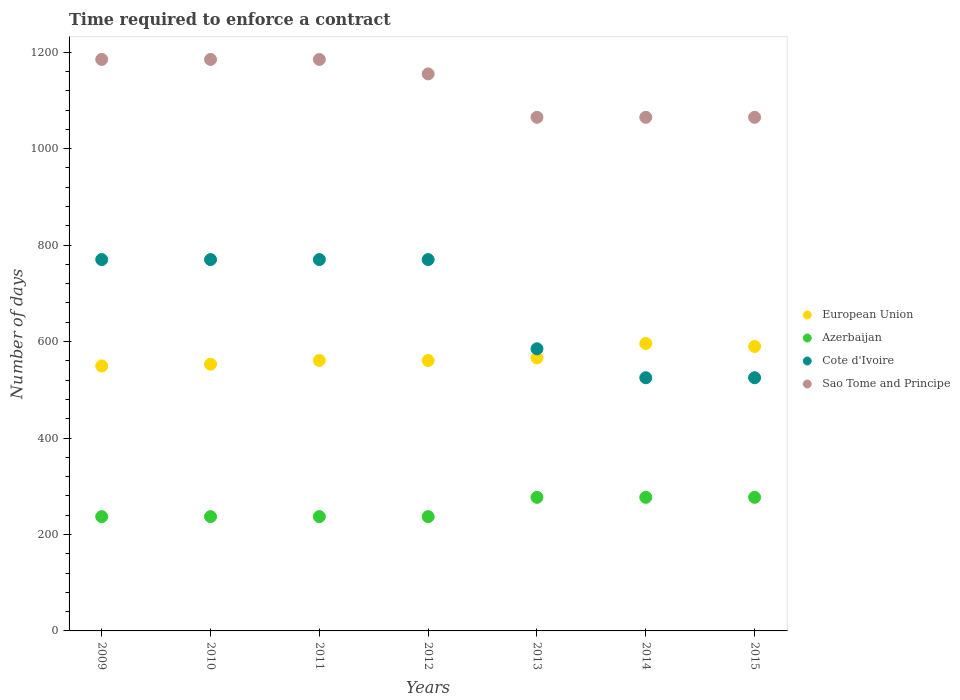How many different coloured dotlines are there?
Offer a very short reply. 4. What is the number of days required to enforce a contract in Sao Tome and Principe in 2015?
Your answer should be compact. 1065. Across all years, what is the maximum number of days required to enforce a contract in European Union?
Offer a terse response. 596.04. Across all years, what is the minimum number of days required to enforce a contract in Sao Tome and Principe?
Keep it short and to the point. 1065. What is the total number of days required to enforce a contract in Azerbaijan in the graph?
Provide a short and direct response. 1779. What is the difference between the number of days required to enforce a contract in Azerbaijan in 2010 and that in 2013?
Offer a very short reply. -40. What is the difference between the number of days required to enforce a contract in Cote d'Ivoire in 2011 and the number of days required to enforce a contract in Sao Tome and Principe in 2013?
Your response must be concise. -295. What is the average number of days required to enforce a contract in Cote d'Ivoire per year?
Keep it short and to the point. 673.57. In the year 2012, what is the difference between the number of days required to enforce a contract in European Union and number of days required to enforce a contract in Azerbaijan?
Your answer should be very brief. 323.61. In how many years, is the number of days required to enforce a contract in Cote d'Ivoire greater than 1080 days?
Offer a terse response. 0. What is the ratio of the number of days required to enforce a contract in Azerbaijan in 2009 to that in 2010?
Make the answer very short. 1. Is the difference between the number of days required to enforce a contract in European Union in 2010 and 2013 greater than the difference between the number of days required to enforce a contract in Azerbaijan in 2010 and 2013?
Make the answer very short. Yes. What is the difference between the highest and the lowest number of days required to enforce a contract in European Union?
Offer a very short reply. 46.67. In how many years, is the number of days required to enforce a contract in European Union greater than the average number of days required to enforce a contract in European Union taken over all years?
Keep it short and to the point. 2. Is the sum of the number of days required to enforce a contract in European Union in 2012 and 2014 greater than the maximum number of days required to enforce a contract in Azerbaijan across all years?
Keep it short and to the point. Yes. Is it the case that in every year, the sum of the number of days required to enforce a contract in European Union and number of days required to enforce a contract in Azerbaijan  is greater than the sum of number of days required to enforce a contract in Cote d'Ivoire and number of days required to enforce a contract in Sao Tome and Principe?
Provide a succinct answer. Yes. Is it the case that in every year, the sum of the number of days required to enforce a contract in Cote d'Ivoire and number of days required to enforce a contract in European Union  is greater than the number of days required to enforce a contract in Azerbaijan?
Give a very brief answer. Yes. Is the number of days required to enforce a contract in Cote d'Ivoire strictly greater than the number of days required to enforce a contract in Azerbaijan over the years?
Your answer should be very brief. Yes. Is the number of days required to enforce a contract in Cote d'Ivoire strictly less than the number of days required to enforce a contract in Azerbaijan over the years?
Your answer should be compact. No. How many dotlines are there?
Your answer should be compact. 4. How many years are there in the graph?
Your answer should be compact. 7. Are the values on the major ticks of Y-axis written in scientific E-notation?
Provide a succinct answer. No. Does the graph contain any zero values?
Your answer should be compact. No. Does the graph contain grids?
Your response must be concise. No. How many legend labels are there?
Make the answer very short. 4. What is the title of the graph?
Keep it short and to the point. Time required to enforce a contract. What is the label or title of the Y-axis?
Provide a short and direct response. Number of days. What is the Number of days of European Union in 2009?
Make the answer very short. 549.37. What is the Number of days of Azerbaijan in 2009?
Provide a short and direct response. 237. What is the Number of days of Cote d'Ivoire in 2009?
Make the answer very short. 770. What is the Number of days of Sao Tome and Principe in 2009?
Keep it short and to the point. 1185. What is the Number of days in European Union in 2010?
Your response must be concise. 553.07. What is the Number of days in Azerbaijan in 2010?
Give a very brief answer. 237. What is the Number of days in Cote d'Ivoire in 2010?
Give a very brief answer. 770. What is the Number of days of Sao Tome and Principe in 2010?
Keep it short and to the point. 1185. What is the Number of days of European Union in 2011?
Give a very brief answer. 560.82. What is the Number of days in Azerbaijan in 2011?
Your answer should be very brief. 237. What is the Number of days in Cote d'Ivoire in 2011?
Your response must be concise. 770. What is the Number of days of Sao Tome and Principe in 2011?
Make the answer very short. 1185. What is the Number of days in European Union in 2012?
Make the answer very short. 560.61. What is the Number of days of Azerbaijan in 2012?
Keep it short and to the point. 237. What is the Number of days of Cote d'Ivoire in 2012?
Offer a very short reply. 770. What is the Number of days in Sao Tome and Principe in 2012?
Offer a terse response. 1155. What is the Number of days of European Union in 2013?
Your answer should be very brief. 566.04. What is the Number of days in Azerbaijan in 2013?
Ensure brevity in your answer.  277. What is the Number of days in Cote d'Ivoire in 2013?
Offer a terse response. 585. What is the Number of days in Sao Tome and Principe in 2013?
Provide a succinct answer. 1065. What is the Number of days in European Union in 2014?
Your answer should be compact. 596.04. What is the Number of days of Azerbaijan in 2014?
Provide a short and direct response. 277. What is the Number of days in Cote d'Ivoire in 2014?
Your answer should be compact. 525. What is the Number of days in Sao Tome and Principe in 2014?
Keep it short and to the point. 1065. What is the Number of days of European Union in 2015?
Provide a succinct answer. 589.79. What is the Number of days of Azerbaijan in 2015?
Offer a terse response. 277. What is the Number of days of Cote d'Ivoire in 2015?
Offer a very short reply. 525. What is the Number of days in Sao Tome and Principe in 2015?
Offer a very short reply. 1065. Across all years, what is the maximum Number of days in European Union?
Offer a very short reply. 596.04. Across all years, what is the maximum Number of days in Azerbaijan?
Offer a very short reply. 277. Across all years, what is the maximum Number of days of Cote d'Ivoire?
Your answer should be very brief. 770. Across all years, what is the maximum Number of days of Sao Tome and Principe?
Offer a terse response. 1185. Across all years, what is the minimum Number of days in European Union?
Make the answer very short. 549.37. Across all years, what is the minimum Number of days in Azerbaijan?
Your response must be concise. 237. Across all years, what is the minimum Number of days of Cote d'Ivoire?
Give a very brief answer. 525. Across all years, what is the minimum Number of days in Sao Tome and Principe?
Keep it short and to the point. 1065. What is the total Number of days of European Union in the graph?
Your answer should be compact. 3975.73. What is the total Number of days of Azerbaijan in the graph?
Your response must be concise. 1779. What is the total Number of days of Cote d'Ivoire in the graph?
Keep it short and to the point. 4715. What is the total Number of days in Sao Tome and Principe in the graph?
Your response must be concise. 7905. What is the difference between the Number of days in European Union in 2009 and that in 2010?
Your answer should be compact. -3.7. What is the difference between the Number of days in Azerbaijan in 2009 and that in 2010?
Offer a very short reply. 0. What is the difference between the Number of days in European Union in 2009 and that in 2011?
Offer a terse response. -11.45. What is the difference between the Number of days in Cote d'Ivoire in 2009 and that in 2011?
Offer a very short reply. 0. What is the difference between the Number of days in Sao Tome and Principe in 2009 and that in 2011?
Provide a succinct answer. 0. What is the difference between the Number of days of European Union in 2009 and that in 2012?
Your answer should be compact. -11.24. What is the difference between the Number of days of Cote d'Ivoire in 2009 and that in 2012?
Keep it short and to the point. 0. What is the difference between the Number of days of Sao Tome and Principe in 2009 and that in 2012?
Ensure brevity in your answer.  30. What is the difference between the Number of days of European Union in 2009 and that in 2013?
Give a very brief answer. -16.67. What is the difference between the Number of days in Azerbaijan in 2009 and that in 2013?
Offer a terse response. -40. What is the difference between the Number of days of Cote d'Ivoire in 2009 and that in 2013?
Provide a succinct answer. 185. What is the difference between the Number of days in Sao Tome and Principe in 2009 and that in 2013?
Give a very brief answer. 120. What is the difference between the Number of days of European Union in 2009 and that in 2014?
Provide a succinct answer. -46.67. What is the difference between the Number of days in Cote d'Ivoire in 2009 and that in 2014?
Give a very brief answer. 245. What is the difference between the Number of days of Sao Tome and Principe in 2009 and that in 2014?
Keep it short and to the point. 120. What is the difference between the Number of days of European Union in 2009 and that in 2015?
Keep it short and to the point. -40.42. What is the difference between the Number of days in Azerbaijan in 2009 and that in 2015?
Make the answer very short. -40. What is the difference between the Number of days in Cote d'Ivoire in 2009 and that in 2015?
Your answer should be very brief. 245. What is the difference between the Number of days of Sao Tome and Principe in 2009 and that in 2015?
Your answer should be compact. 120. What is the difference between the Number of days in European Union in 2010 and that in 2011?
Ensure brevity in your answer.  -7.75. What is the difference between the Number of days of Azerbaijan in 2010 and that in 2011?
Your response must be concise. 0. What is the difference between the Number of days in Cote d'Ivoire in 2010 and that in 2011?
Your response must be concise. 0. What is the difference between the Number of days in European Union in 2010 and that in 2012?
Make the answer very short. -7.53. What is the difference between the Number of days of Sao Tome and Principe in 2010 and that in 2012?
Make the answer very short. 30. What is the difference between the Number of days of European Union in 2010 and that in 2013?
Make the answer very short. -12.96. What is the difference between the Number of days in Azerbaijan in 2010 and that in 2013?
Ensure brevity in your answer.  -40. What is the difference between the Number of days of Cote d'Ivoire in 2010 and that in 2013?
Offer a terse response. 185. What is the difference between the Number of days in Sao Tome and Principe in 2010 and that in 2013?
Offer a terse response. 120. What is the difference between the Number of days in European Union in 2010 and that in 2014?
Your answer should be compact. -42.96. What is the difference between the Number of days of Azerbaijan in 2010 and that in 2014?
Offer a terse response. -40. What is the difference between the Number of days of Cote d'Ivoire in 2010 and that in 2014?
Provide a short and direct response. 245. What is the difference between the Number of days of Sao Tome and Principe in 2010 and that in 2014?
Offer a terse response. 120. What is the difference between the Number of days in European Union in 2010 and that in 2015?
Provide a short and direct response. -36.71. What is the difference between the Number of days in Cote d'Ivoire in 2010 and that in 2015?
Ensure brevity in your answer.  245. What is the difference between the Number of days of Sao Tome and Principe in 2010 and that in 2015?
Offer a very short reply. 120. What is the difference between the Number of days in European Union in 2011 and that in 2012?
Offer a very short reply. 0.21. What is the difference between the Number of days in Azerbaijan in 2011 and that in 2012?
Ensure brevity in your answer.  0. What is the difference between the Number of days of Cote d'Ivoire in 2011 and that in 2012?
Ensure brevity in your answer.  0. What is the difference between the Number of days of Sao Tome and Principe in 2011 and that in 2012?
Make the answer very short. 30. What is the difference between the Number of days in European Union in 2011 and that in 2013?
Ensure brevity in your answer.  -5.21. What is the difference between the Number of days of Azerbaijan in 2011 and that in 2013?
Give a very brief answer. -40. What is the difference between the Number of days of Cote d'Ivoire in 2011 and that in 2013?
Give a very brief answer. 185. What is the difference between the Number of days of Sao Tome and Principe in 2011 and that in 2013?
Offer a terse response. 120. What is the difference between the Number of days of European Union in 2011 and that in 2014?
Offer a very short reply. -35.21. What is the difference between the Number of days in Cote d'Ivoire in 2011 and that in 2014?
Offer a very short reply. 245. What is the difference between the Number of days in Sao Tome and Principe in 2011 and that in 2014?
Offer a terse response. 120. What is the difference between the Number of days of European Union in 2011 and that in 2015?
Your answer should be compact. -28.96. What is the difference between the Number of days of Cote d'Ivoire in 2011 and that in 2015?
Keep it short and to the point. 245. What is the difference between the Number of days in Sao Tome and Principe in 2011 and that in 2015?
Make the answer very short. 120. What is the difference between the Number of days of European Union in 2012 and that in 2013?
Offer a terse response. -5.43. What is the difference between the Number of days in Cote d'Ivoire in 2012 and that in 2013?
Your response must be concise. 185. What is the difference between the Number of days of Sao Tome and Principe in 2012 and that in 2013?
Offer a terse response. 90. What is the difference between the Number of days in European Union in 2012 and that in 2014?
Keep it short and to the point. -35.43. What is the difference between the Number of days of Azerbaijan in 2012 and that in 2014?
Keep it short and to the point. -40. What is the difference between the Number of days of Cote d'Ivoire in 2012 and that in 2014?
Offer a very short reply. 245. What is the difference between the Number of days in Sao Tome and Principe in 2012 and that in 2014?
Ensure brevity in your answer.  90. What is the difference between the Number of days of European Union in 2012 and that in 2015?
Provide a short and direct response. -29.18. What is the difference between the Number of days of Azerbaijan in 2012 and that in 2015?
Keep it short and to the point. -40. What is the difference between the Number of days in Cote d'Ivoire in 2012 and that in 2015?
Offer a terse response. 245. What is the difference between the Number of days in European Union in 2013 and that in 2015?
Keep it short and to the point. -23.75. What is the difference between the Number of days in Azerbaijan in 2013 and that in 2015?
Offer a terse response. 0. What is the difference between the Number of days in Sao Tome and Principe in 2013 and that in 2015?
Offer a very short reply. 0. What is the difference between the Number of days in European Union in 2014 and that in 2015?
Make the answer very short. 6.25. What is the difference between the Number of days in Cote d'Ivoire in 2014 and that in 2015?
Your response must be concise. 0. What is the difference between the Number of days of Sao Tome and Principe in 2014 and that in 2015?
Your answer should be very brief. 0. What is the difference between the Number of days in European Union in 2009 and the Number of days in Azerbaijan in 2010?
Your answer should be very brief. 312.37. What is the difference between the Number of days in European Union in 2009 and the Number of days in Cote d'Ivoire in 2010?
Provide a short and direct response. -220.63. What is the difference between the Number of days of European Union in 2009 and the Number of days of Sao Tome and Principe in 2010?
Provide a succinct answer. -635.63. What is the difference between the Number of days in Azerbaijan in 2009 and the Number of days in Cote d'Ivoire in 2010?
Offer a very short reply. -533. What is the difference between the Number of days of Azerbaijan in 2009 and the Number of days of Sao Tome and Principe in 2010?
Provide a succinct answer. -948. What is the difference between the Number of days in Cote d'Ivoire in 2009 and the Number of days in Sao Tome and Principe in 2010?
Your answer should be compact. -415. What is the difference between the Number of days of European Union in 2009 and the Number of days of Azerbaijan in 2011?
Keep it short and to the point. 312.37. What is the difference between the Number of days in European Union in 2009 and the Number of days in Cote d'Ivoire in 2011?
Ensure brevity in your answer.  -220.63. What is the difference between the Number of days in European Union in 2009 and the Number of days in Sao Tome and Principe in 2011?
Give a very brief answer. -635.63. What is the difference between the Number of days of Azerbaijan in 2009 and the Number of days of Cote d'Ivoire in 2011?
Provide a short and direct response. -533. What is the difference between the Number of days in Azerbaijan in 2009 and the Number of days in Sao Tome and Principe in 2011?
Offer a very short reply. -948. What is the difference between the Number of days of Cote d'Ivoire in 2009 and the Number of days of Sao Tome and Principe in 2011?
Ensure brevity in your answer.  -415. What is the difference between the Number of days of European Union in 2009 and the Number of days of Azerbaijan in 2012?
Provide a succinct answer. 312.37. What is the difference between the Number of days of European Union in 2009 and the Number of days of Cote d'Ivoire in 2012?
Provide a succinct answer. -220.63. What is the difference between the Number of days in European Union in 2009 and the Number of days in Sao Tome and Principe in 2012?
Give a very brief answer. -605.63. What is the difference between the Number of days of Azerbaijan in 2009 and the Number of days of Cote d'Ivoire in 2012?
Your response must be concise. -533. What is the difference between the Number of days of Azerbaijan in 2009 and the Number of days of Sao Tome and Principe in 2012?
Ensure brevity in your answer.  -918. What is the difference between the Number of days in Cote d'Ivoire in 2009 and the Number of days in Sao Tome and Principe in 2012?
Your answer should be compact. -385. What is the difference between the Number of days in European Union in 2009 and the Number of days in Azerbaijan in 2013?
Your response must be concise. 272.37. What is the difference between the Number of days in European Union in 2009 and the Number of days in Cote d'Ivoire in 2013?
Offer a very short reply. -35.63. What is the difference between the Number of days in European Union in 2009 and the Number of days in Sao Tome and Principe in 2013?
Provide a short and direct response. -515.63. What is the difference between the Number of days of Azerbaijan in 2009 and the Number of days of Cote d'Ivoire in 2013?
Your answer should be compact. -348. What is the difference between the Number of days in Azerbaijan in 2009 and the Number of days in Sao Tome and Principe in 2013?
Offer a terse response. -828. What is the difference between the Number of days of Cote d'Ivoire in 2009 and the Number of days of Sao Tome and Principe in 2013?
Provide a short and direct response. -295. What is the difference between the Number of days of European Union in 2009 and the Number of days of Azerbaijan in 2014?
Give a very brief answer. 272.37. What is the difference between the Number of days of European Union in 2009 and the Number of days of Cote d'Ivoire in 2014?
Make the answer very short. 24.37. What is the difference between the Number of days in European Union in 2009 and the Number of days in Sao Tome and Principe in 2014?
Keep it short and to the point. -515.63. What is the difference between the Number of days of Azerbaijan in 2009 and the Number of days of Cote d'Ivoire in 2014?
Provide a short and direct response. -288. What is the difference between the Number of days in Azerbaijan in 2009 and the Number of days in Sao Tome and Principe in 2014?
Your answer should be very brief. -828. What is the difference between the Number of days of Cote d'Ivoire in 2009 and the Number of days of Sao Tome and Principe in 2014?
Offer a very short reply. -295. What is the difference between the Number of days in European Union in 2009 and the Number of days in Azerbaijan in 2015?
Make the answer very short. 272.37. What is the difference between the Number of days of European Union in 2009 and the Number of days of Cote d'Ivoire in 2015?
Offer a very short reply. 24.37. What is the difference between the Number of days in European Union in 2009 and the Number of days in Sao Tome and Principe in 2015?
Provide a succinct answer. -515.63. What is the difference between the Number of days of Azerbaijan in 2009 and the Number of days of Cote d'Ivoire in 2015?
Provide a succinct answer. -288. What is the difference between the Number of days of Azerbaijan in 2009 and the Number of days of Sao Tome and Principe in 2015?
Keep it short and to the point. -828. What is the difference between the Number of days of Cote d'Ivoire in 2009 and the Number of days of Sao Tome and Principe in 2015?
Your answer should be compact. -295. What is the difference between the Number of days in European Union in 2010 and the Number of days in Azerbaijan in 2011?
Give a very brief answer. 316.07. What is the difference between the Number of days of European Union in 2010 and the Number of days of Cote d'Ivoire in 2011?
Ensure brevity in your answer.  -216.93. What is the difference between the Number of days in European Union in 2010 and the Number of days in Sao Tome and Principe in 2011?
Make the answer very short. -631.93. What is the difference between the Number of days in Azerbaijan in 2010 and the Number of days in Cote d'Ivoire in 2011?
Your answer should be very brief. -533. What is the difference between the Number of days in Azerbaijan in 2010 and the Number of days in Sao Tome and Principe in 2011?
Your response must be concise. -948. What is the difference between the Number of days of Cote d'Ivoire in 2010 and the Number of days of Sao Tome and Principe in 2011?
Your answer should be very brief. -415. What is the difference between the Number of days of European Union in 2010 and the Number of days of Azerbaijan in 2012?
Offer a terse response. 316.07. What is the difference between the Number of days in European Union in 2010 and the Number of days in Cote d'Ivoire in 2012?
Provide a short and direct response. -216.93. What is the difference between the Number of days in European Union in 2010 and the Number of days in Sao Tome and Principe in 2012?
Offer a very short reply. -601.93. What is the difference between the Number of days in Azerbaijan in 2010 and the Number of days in Cote d'Ivoire in 2012?
Your answer should be compact. -533. What is the difference between the Number of days of Azerbaijan in 2010 and the Number of days of Sao Tome and Principe in 2012?
Offer a terse response. -918. What is the difference between the Number of days of Cote d'Ivoire in 2010 and the Number of days of Sao Tome and Principe in 2012?
Your answer should be very brief. -385. What is the difference between the Number of days in European Union in 2010 and the Number of days in Azerbaijan in 2013?
Offer a terse response. 276.07. What is the difference between the Number of days of European Union in 2010 and the Number of days of Cote d'Ivoire in 2013?
Make the answer very short. -31.93. What is the difference between the Number of days of European Union in 2010 and the Number of days of Sao Tome and Principe in 2013?
Your answer should be very brief. -511.93. What is the difference between the Number of days in Azerbaijan in 2010 and the Number of days in Cote d'Ivoire in 2013?
Offer a very short reply. -348. What is the difference between the Number of days in Azerbaijan in 2010 and the Number of days in Sao Tome and Principe in 2013?
Provide a succinct answer. -828. What is the difference between the Number of days in Cote d'Ivoire in 2010 and the Number of days in Sao Tome and Principe in 2013?
Provide a short and direct response. -295. What is the difference between the Number of days of European Union in 2010 and the Number of days of Azerbaijan in 2014?
Provide a short and direct response. 276.07. What is the difference between the Number of days in European Union in 2010 and the Number of days in Cote d'Ivoire in 2014?
Your answer should be very brief. 28.07. What is the difference between the Number of days in European Union in 2010 and the Number of days in Sao Tome and Principe in 2014?
Give a very brief answer. -511.93. What is the difference between the Number of days of Azerbaijan in 2010 and the Number of days of Cote d'Ivoire in 2014?
Your answer should be compact. -288. What is the difference between the Number of days in Azerbaijan in 2010 and the Number of days in Sao Tome and Principe in 2014?
Your response must be concise. -828. What is the difference between the Number of days in Cote d'Ivoire in 2010 and the Number of days in Sao Tome and Principe in 2014?
Make the answer very short. -295. What is the difference between the Number of days of European Union in 2010 and the Number of days of Azerbaijan in 2015?
Keep it short and to the point. 276.07. What is the difference between the Number of days of European Union in 2010 and the Number of days of Cote d'Ivoire in 2015?
Keep it short and to the point. 28.07. What is the difference between the Number of days in European Union in 2010 and the Number of days in Sao Tome and Principe in 2015?
Make the answer very short. -511.93. What is the difference between the Number of days of Azerbaijan in 2010 and the Number of days of Cote d'Ivoire in 2015?
Give a very brief answer. -288. What is the difference between the Number of days in Azerbaijan in 2010 and the Number of days in Sao Tome and Principe in 2015?
Your response must be concise. -828. What is the difference between the Number of days of Cote d'Ivoire in 2010 and the Number of days of Sao Tome and Principe in 2015?
Keep it short and to the point. -295. What is the difference between the Number of days of European Union in 2011 and the Number of days of Azerbaijan in 2012?
Provide a succinct answer. 323.82. What is the difference between the Number of days in European Union in 2011 and the Number of days in Cote d'Ivoire in 2012?
Ensure brevity in your answer.  -209.18. What is the difference between the Number of days in European Union in 2011 and the Number of days in Sao Tome and Principe in 2012?
Provide a short and direct response. -594.18. What is the difference between the Number of days in Azerbaijan in 2011 and the Number of days in Cote d'Ivoire in 2012?
Ensure brevity in your answer.  -533. What is the difference between the Number of days in Azerbaijan in 2011 and the Number of days in Sao Tome and Principe in 2012?
Give a very brief answer. -918. What is the difference between the Number of days of Cote d'Ivoire in 2011 and the Number of days of Sao Tome and Principe in 2012?
Ensure brevity in your answer.  -385. What is the difference between the Number of days of European Union in 2011 and the Number of days of Azerbaijan in 2013?
Your answer should be very brief. 283.82. What is the difference between the Number of days of European Union in 2011 and the Number of days of Cote d'Ivoire in 2013?
Your answer should be compact. -24.18. What is the difference between the Number of days of European Union in 2011 and the Number of days of Sao Tome and Principe in 2013?
Keep it short and to the point. -504.18. What is the difference between the Number of days in Azerbaijan in 2011 and the Number of days in Cote d'Ivoire in 2013?
Keep it short and to the point. -348. What is the difference between the Number of days of Azerbaijan in 2011 and the Number of days of Sao Tome and Principe in 2013?
Your response must be concise. -828. What is the difference between the Number of days of Cote d'Ivoire in 2011 and the Number of days of Sao Tome and Principe in 2013?
Your answer should be compact. -295. What is the difference between the Number of days in European Union in 2011 and the Number of days in Azerbaijan in 2014?
Make the answer very short. 283.82. What is the difference between the Number of days of European Union in 2011 and the Number of days of Cote d'Ivoire in 2014?
Your answer should be compact. 35.82. What is the difference between the Number of days of European Union in 2011 and the Number of days of Sao Tome and Principe in 2014?
Your response must be concise. -504.18. What is the difference between the Number of days in Azerbaijan in 2011 and the Number of days in Cote d'Ivoire in 2014?
Provide a succinct answer. -288. What is the difference between the Number of days in Azerbaijan in 2011 and the Number of days in Sao Tome and Principe in 2014?
Make the answer very short. -828. What is the difference between the Number of days of Cote d'Ivoire in 2011 and the Number of days of Sao Tome and Principe in 2014?
Your answer should be very brief. -295. What is the difference between the Number of days of European Union in 2011 and the Number of days of Azerbaijan in 2015?
Keep it short and to the point. 283.82. What is the difference between the Number of days of European Union in 2011 and the Number of days of Cote d'Ivoire in 2015?
Your answer should be compact. 35.82. What is the difference between the Number of days in European Union in 2011 and the Number of days in Sao Tome and Principe in 2015?
Offer a terse response. -504.18. What is the difference between the Number of days in Azerbaijan in 2011 and the Number of days in Cote d'Ivoire in 2015?
Your answer should be compact. -288. What is the difference between the Number of days in Azerbaijan in 2011 and the Number of days in Sao Tome and Principe in 2015?
Make the answer very short. -828. What is the difference between the Number of days in Cote d'Ivoire in 2011 and the Number of days in Sao Tome and Principe in 2015?
Give a very brief answer. -295. What is the difference between the Number of days in European Union in 2012 and the Number of days in Azerbaijan in 2013?
Provide a succinct answer. 283.61. What is the difference between the Number of days of European Union in 2012 and the Number of days of Cote d'Ivoire in 2013?
Your answer should be compact. -24.39. What is the difference between the Number of days of European Union in 2012 and the Number of days of Sao Tome and Principe in 2013?
Keep it short and to the point. -504.39. What is the difference between the Number of days in Azerbaijan in 2012 and the Number of days in Cote d'Ivoire in 2013?
Your response must be concise. -348. What is the difference between the Number of days of Azerbaijan in 2012 and the Number of days of Sao Tome and Principe in 2013?
Provide a succinct answer. -828. What is the difference between the Number of days in Cote d'Ivoire in 2012 and the Number of days in Sao Tome and Principe in 2013?
Your answer should be very brief. -295. What is the difference between the Number of days of European Union in 2012 and the Number of days of Azerbaijan in 2014?
Make the answer very short. 283.61. What is the difference between the Number of days in European Union in 2012 and the Number of days in Cote d'Ivoire in 2014?
Offer a very short reply. 35.61. What is the difference between the Number of days of European Union in 2012 and the Number of days of Sao Tome and Principe in 2014?
Make the answer very short. -504.39. What is the difference between the Number of days of Azerbaijan in 2012 and the Number of days of Cote d'Ivoire in 2014?
Provide a short and direct response. -288. What is the difference between the Number of days of Azerbaijan in 2012 and the Number of days of Sao Tome and Principe in 2014?
Your response must be concise. -828. What is the difference between the Number of days in Cote d'Ivoire in 2012 and the Number of days in Sao Tome and Principe in 2014?
Make the answer very short. -295. What is the difference between the Number of days of European Union in 2012 and the Number of days of Azerbaijan in 2015?
Ensure brevity in your answer.  283.61. What is the difference between the Number of days of European Union in 2012 and the Number of days of Cote d'Ivoire in 2015?
Give a very brief answer. 35.61. What is the difference between the Number of days in European Union in 2012 and the Number of days in Sao Tome and Principe in 2015?
Offer a terse response. -504.39. What is the difference between the Number of days in Azerbaijan in 2012 and the Number of days in Cote d'Ivoire in 2015?
Your answer should be very brief. -288. What is the difference between the Number of days of Azerbaijan in 2012 and the Number of days of Sao Tome and Principe in 2015?
Your answer should be very brief. -828. What is the difference between the Number of days of Cote d'Ivoire in 2012 and the Number of days of Sao Tome and Principe in 2015?
Your answer should be compact. -295. What is the difference between the Number of days of European Union in 2013 and the Number of days of Azerbaijan in 2014?
Offer a terse response. 289.04. What is the difference between the Number of days of European Union in 2013 and the Number of days of Cote d'Ivoire in 2014?
Offer a terse response. 41.04. What is the difference between the Number of days of European Union in 2013 and the Number of days of Sao Tome and Principe in 2014?
Offer a very short reply. -498.96. What is the difference between the Number of days in Azerbaijan in 2013 and the Number of days in Cote d'Ivoire in 2014?
Provide a short and direct response. -248. What is the difference between the Number of days in Azerbaijan in 2013 and the Number of days in Sao Tome and Principe in 2014?
Ensure brevity in your answer.  -788. What is the difference between the Number of days of Cote d'Ivoire in 2013 and the Number of days of Sao Tome and Principe in 2014?
Offer a very short reply. -480. What is the difference between the Number of days of European Union in 2013 and the Number of days of Azerbaijan in 2015?
Your answer should be very brief. 289.04. What is the difference between the Number of days in European Union in 2013 and the Number of days in Cote d'Ivoire in 2015?
Offer a terse response. 41.04. What is the difference between the Number of days of European Union in 2013 and the Number of days of Sao Tome and Principe in 2015?
Your answer should be very brief. -498.96. What is the difference between the Number of days in Azerbaijan in 2013 and the Number of days in Cote d'Ivoire in 2015?
Provide a succinct answer. -248. What is the difference between the Number of days of Azerbaijan in 2013 and the Number of days of Sao Tome and Principe in 2015?
Ensure brevity in your answer.  -788. What is the difference between the Number of days of Cote d'Ivoire in 2013 and the Number of days of Sao Tome and Principe in 2015?
Make the answer very short. -480. What is the difference between the Number of days of European Union in 2014 and the Number of days of Azerbaijan in 2015?
Your answer should be compact. 319.04. What is the difference between the Number of days of European Union in 2014 and the Number of days of Cote d'Ivoire in 2015?
Ensure brevity in your answer.  71.04. What is the difference between the Number of days in European Union in 2014 and the Number of days in Sao Tome and Principe in 2015?
Ensure brevity in your answer.  -468.96. What is the difference between the Number of days in Azerbaijan in 2014 and the Number of days in Cote d'Ivoire in 2015?
Your answer should be very brief. -248. What is the difference between the Number of days of Azerbaijan in 2014 and the Number of days of Sao Tome and Principe in 2015?
Offer a very short reply. -788. What is the difference between the Number of days of Cote d'Ivoire in 2014 and the Number of days of Sao Tome and Principe in 2015?
Provide a short and direct response. -540. What is the average Number of days in European Union per year?
Offer a terse response. 567.96. What is the average Number of days in Azerbaijan per year?
Offer a very short reply. 254.14. What is the average Number of days in Cote d'Ivoire per year?
Make the answer very short. 673.57. What is the average Number of days of Sao Tome and Principe per year?
Your answer should be very brief. 1129.29. In the year 2009, what is the difference between the Number of days of European Union and Number of days of Azerbaijan?
Give a very brief answer. 312.37. In the year 2009, what is the difference between the Number of days in European Union and Number of days in Cote d'Ivoire?
Give a very brief answer. -220.63. In the year 2009, what is the difference between the Number of days in European Union and Number of days in Sao Tome and Principe?
Offer a terse response. -635.63. In the year 2009, what is the difference between the Number of days in Azerbaijan and Number of days in Cote d'Ivoire?
Offer a terse response. -533. In the year 2009, what is the difference between the Number of days of Azerbaijan and Number of days of Sao Tome and Principe?
Offer a very short reply. -948. In the year 2009, what is the difference between the Number of days in Cote d'Ivoire and Number of days in Sao Tome and Principe?
Your answer should be compact. -415. In the year 2010, what is the difference between the Number of days in European Union and Number of days in Azerbaijan?
Ensure brevity in your answer.  316.07. In the year 2010, what is the difference between the Number of days of European Union and Number of days of Cote d'Ivoire?
Provide a succinct answer. -216.93. In the year 2010, what is the difference between the Number of days of European Union and Number of days of Sao Tome and Principe?
Provide a succinct answer. -631.93. In the year 2010, what is the difference between the Number of days in Azerbaijan and Number of days in Cote d'Ivoire?
Your response must be concise. -533. In the year 2010, what is the difference between the Number of days of Azerbaijan and Number of days of Sao Tome and Principe?
Offer a terse response. -948. In the year 2010, what is the difference between the Number of days of Cote d'Ivoire and Number of days of Sao Tome and Principe?
Keep it short and to the point. -415. In the year 2011, what is the difference between the Number of days in European Union and Number of days in Azerbaijan?
Provide a short and direct response. 323.82. In the year 2011, what is the difference between the Number of days of European Union and Number of days of Cote d'Ivoire?
Keep it short and to the point. -209.18. In the year 2011, what is the difference between the Number of days of European Union and Number of days of Sao Tome and Principe?
Make the answer very short. -624.18. In the year 2011, what is the difference between the Number of days in Azerbaijan and Number of days in Cote d'Ivoire?
Offer a terse response. -533. In the year 2011, what is the difference between the Number of days of Azerbaijan and Number of days of Sao Tome and Principe?
Provide a short and direct response. -948. In the year 2011, what is the difference between the Number of days in Cote d'Ivoire and Number of days in Sao Tome and Principe?
Make the answer very short. -415. In the year 2012, what is the difference between the Number of days of European Union and Number of days of Azerbaijan?
Your answer should be compact. 323.61. In the year 2012, what is the difference between the Number of days in European Union and Number of days in Cote d'Ivoire?
Offer a terse response. -209.39. In the year 2012, what is the difference between the Number of days in European Union and Number of days in Sao Tome and Principe?
Ensure brevity in your answer.  -594.39. In the year 2012, what is the difference between the Number of days of Azerbaijan and Number of days of Cote d'Ivoire?
Offer a very short reply. -533. In the year 2012, what is the difference between the Number of days in Azerbaijan and Number of days in Sao Tome and Principe?
Keep it short and to the point. -918. In the year 2012, what is the difference between the Number of days in Cote d'Ivoire and Number of days in Sao Tome and Principe?
Give a very brief answer. -385. In the year 2013, what is the difference between the Number of days of European Union and Number of days of Azerbaijan?
Give a very brief answer. 289.04. In the year 2013, what is the difference between the Number of days of European Union and Number of days of Cote d'Ivoire?
Ensure brevity in your answer.  -18.96. In the year 2013, what is the difference between the Number of days of European Union and Number of days of Sao Tome and Principe?
Your answer should be very brief. -498.96. In the year 2013, what is the difference between the Number of days in Azerbaijan and Number of days in Cote d'Ivoire?
Provide a short and direct response. -308. In the year 2013, what is the difference between the Number of days of Azerbaijan and Number of days of Sao Tome and Principe?
Offer a terse response. -788. In the year 2013, what is the difference between the Number of days in Cote d'Ivoire and Number of days in Sao Tome and Principe?
Offer a very short reply. -480. In the year 2014, what is the difference between the Number of days in European Union and Number of days in Azerbaijan?
Provide a succinct answer. 319.04. In the year 2014, what is the difference between the Number of days of European Union and Number of days of Cote d'Ivoire?
Keep it short and to the point. 71.04. In the year 2014, what is the difference between the Number of days in European Union and Number of days in Sao Tome and Principe?
Keep it short and to the point. -468.96. In the year 2014, what is the difference between the Number of days of Azerbaijan and Number of days of Cote d'Ivoire?
Offer a terse response. -248. In the year 2014, what is the difference between the Number of days of Azerbaijan and Number of days of Sao Tome and Principe?
Your answer should be very brief. -788. In the year 2014, what is the difference between the Number of days of Cote d'Ivoire and Number of days of Sao Tome and Principe?
Make the answer very short. -540. In the year 2015, what is the difference between the Number of days of European Union and Number of days of Azerbaijan?
Keep it short and to the point. 312.79. In the year 2015, what is the difference between the Number of days of European Union and Number of days of Cote d'Ivoire?
Give a very brief answer. 64.79. In the year 2015, what is the difference between the Number of days in European Union and Number of days in Sao Tome and Principe?
Your answer should be very brief. -475.21. In the year 2015, what is the difference between the Number of days in Azerbaijan and Number of days in Cote d'Ivoire?
Offer a terse response. -248. In the year 2015, what is the difference between the Number of days of Azerbaijan and Number of days of Sao Tome and Principe?
Your response must be concise. -788. In the year 2015, what is the difference between the Number of days in Cote d'Ivoire and Number of days in Sao Tome and Principe?
Provide a short and direct response. -540. What is the ratio of the Number of days of Azerbaijan in 2009 to that in 2010?
Your answer should be very brief. 1. What is the ratio of the Number of days of Cote d'Ivoire in 2009 to that in 2010?
Make the answer very short. 1. What is the ratio of the Number of days in Sao Tome and Principe in 2009 to that in 2010?
Offer a very short reply. 1. What is the ratio of the Number of days of European Union in 2009 to that in 2011?
Your answer should be very brief. 0.98. What is the ratio of the Number of days of Azerbaijan in 2009 to that in 2011?
Offer a very short reply. 1. What is the ratio of the Number of days in Sao Tome and Principe in 2009 to that in 2011?
Keep it short and to the point. 1. What is the ratio of the Number of days in European Union in 2009 to that in 2012?
Make the answer very short. 0.98. What is the ratio of the Number of days of Cote d'Ivoire in 2009 to that in 2012?
Make the answer very short. 1. What is the ratio of the Number of days of Sao Tome and Principe in 2009 to that in 2012?
Make the answer very short. 1.03. What is the ratio of the Number of days in European Union in 2009 to that in 2013?
Provide a succinct answer. 0.97. What is the ratio of the Number of days of Azerbaijan in 2009 to that in 2013?
Provide a short and direct response. 0.86. What is the ratio of the Number of days in Cote d'Ivoire in 2009 to that in 2013?
Keep it short and to the point. 1.32. What is the ratio of the Number of days in Sao Tome and Principe in 2009 to that in 2013?
Offer a terse response. 1.11. What is the ratio of the Number of days of European Union in 2009 to that in 2014?
Your answer should be compact. 0.92. What is the ratio of the Number of days of Azerbaijan in 2009 to that in 2014?
Offer a terse response. 0.86. What is the ratio of the Number of days of Cote d'Ivoire in 2009 to that in 2014?
Give a very brief answer. 1.47. What is the ratio of the Number of days in Sao Tome and Principe in 2009 to that in 2014?
Make the answer very short. 1.11. What is the ratio of the Number of days of European Union in 2009 to that in 2015?
Your answer should be compact. 0.93. What is the ratio of the Number of days in Azerbaijan in 2009 to that in 2015?
Offer a terse response. 0.86. What is the ratio of the Number of days of Cote d'Ivoire in 2009 to that in 2015?
Give a very brief answer. 1.47. What is the ratio of the Number of days in Sao Tome and Principe in 2009 to that in 2015?
Your answer should be compact. 1.11. What is the ratio of the Number of days of European Union in 2010 to that in 2011?
Keep it short and to the point. 0.99. What is the ratio of the Number of days in Azerbaijan in 2010 to that in 2011?
Make the answer very short. 1. What is the ratio of the Number of days in Cote d'Ivoire in 2010 to that in 2011?
Your response must be concise. 1. What is the ratio of the Number of days in Sao Tome and Principe in 2010 to that in 2011?
Make the answer very short. 1. What is the ratio of the Number of days in European Union in 2010 to that in 2012?
Provide a short and direct response. 0.99. What is the ratio of the Number of days in Azerbaijan in 2010 to that in 2012?
Provide a succinct answer. 1. What is the ratio of the Number of days of Cote d'Ivoire in 2010 to that in 2012?
Provide a succinct answer. 1. What is the ratio of the Number of days of European Union in 2010 to that in 2013?
Provide a succinct answer. 0.98. What is the ratio of the Number of days of Azerbaijan in 2010 to that in 2013?
Make the answer very short. 0.86. What is the ratio of the Number of days in Cote d'Ivoire in 2010 to that in 2013?
Make the answer very short. 1.32. What is the ratio of the Number of days in Sao Tome and Principe in 2010 to that in 2013?
Offer a terse response. 1.11. What is the ratio of the Number of days in European Union in 2010 to that in 2014?
Make the answer very short. 0.93. What is the ratio of the Number of days of Azerbaijan in 2010 to that in 2014?
Offer a terse response. 0.86. What is the ratio of the Number of days of Cote d'Ivoire in 2010 to that in 2014?
Offer a terse response. 1.47. What is the ratio of the Number of days in Sao Tome and Principe in 2010 to that in 2014?
Offer a terse response. 1.11. What is the ratio of the Number of days in European Union in 2010 to that in 2015?
Keep it short and to the point. 0.94. What is the ratio of the Number of days of Azerbaijan in 2010 to that in 2015?
Make the answer very short. 0.86. What is the ratio of the Number of days in Cote d'Ivoire in 2010 to that in 2015?
Ensure brevity in your answer.  1.47. What is the ratio of the Number of days of Sao Tome and Principe in 2010 to that in 2015?
Provide a succinct answer. 1.11. What is the ratio of the Number of days in Cote d'Ivoire in 2011 to that in 2012?
Offer a terse response. 1. What is the ratio of the Number of days in Sao Tome and Principe in 2011 to that in 2012?
Offer a very short reply. 1.03. What is the ratio of the Number of days of Azerbaijan in 2011 to that in 2013?
Your answer should be compact. 0.86. What is the ratio of the Number of days of Cote d'Ivoire in 2011 to that in 2013?
Make the answer very short. 1.32. What is the ratio of the Number of days in Sao Tome and Principe in 2011 to that in 2013?
Ensure brevity in your answer.  1.11. What is the ratio of the Number of days in European Union in 2011 to that in 2014?
Your answer should be compact. 0.94. What is the ratio of the Number of days in Azerbaijan in 2011 to that in 2014?
Offer a very short reply. 0.86. What is the ratio of the Number of days of Cote d'Ivoire in 2011 to that in 2014?
Your response must be concise. 1.47. What is the ratio of the Number of days in Sao Tome and Principe in 2011 to that in 2014?
Provide a succinct answer. 1.11. What is the ratio of the Number of days of European Union in 2011 to that in 2015?
Make the answer very short. 0.95. What is the ratio of the Number of days in Azerbaijan in 2011 to that in 2015?
Keep it short and to the point. 0.86. What is the ratio of the Number of days of Cote d'Ivoire in 2011 to that in 2015?
Offer a very short reply. 1.47. What is the ratio of the Number of days of Sao Tome and Principe in 2011 to that in 2015?
Provide a succinct answer. 1.11. What is the ratio of the Number of days in Azerbaijan in 2012 to that in 2013?
Ensure brevity in your answer.  0.86. What is the ratio of the Number of days of Cote d'Ivoire in 2012 to that in 2013?
Provide a succinct answer. 1.32. What is the ratio of the Number of days of Sao Tome and Principe in 2012 to that in 2013?
Make the answer very short. 1.08. What is the ratio of the Number of days of European Union in 2012 to that in 2014?
Provide a short and direct response. 0.94. What is the ratio of the Number of days in Azerbaijan in 2012 to that in 2014?
Offer a terse response. 0.86. What is the ratio of the Number of days of Cote d'Ivoire in 2012 to that in 2014?
Keep it short and to the point. 1.47. What is the ratio of the Number of days in Sao Tome and Principe in 2012 to that in 2014?
Make the answer very short. 1.08. What is the ratio of the Number of days of European Union in 2012 to that in 2015?
Provide a short and direct response. 0.95. What is the ratio of the Number of days in Azerbaijan in 2012 to that in 2015?
Keep it short and to the point. 0.86. What is the ratio of the Number of days of Cote d'Ivoire in 2012 to that in 2015?
Offer a terse response. 1.47. What is the ratio of the Number of days of Sao Tome and Principe in 2012 to that in 2015?
Offer a terse response. 1.08. What is the ratio of the Number of days in European Union in 2013 to that in 2014?
Offer a terse response. 0.95. What is the ratio of the Number of days in Cote d'Ivoire in 2013 to that in 2014?
Provide a short and direct response. 1.11. What is the ratio of the Number of days of European Union in 2013 to that in 2015?
Ensure brevity in your answer.  0.96. What is the ratio of the Number of days in Azerbaijan in 2013 to that in 2015?
Give a very brief answer. 1. What is the ratio of the Number of days in Cote d'Ivoire in 2013 to that in 2015?
Your response must be concise. 1.11. What is the ratio of the Number of days of Sao Tome and Principe in 2013 to that in 2015?
Your response must be concise. 1. What is the ratio of the Number of days in European Union in 2014 to that in 2015?
Provide a short and direct response. 1.01. What is the ratio of the Number of days in Azerbaijan in 2014 to that in 2015?
Provide a succinct answer. 1. What is the ratio of the Number of days in Cote d'Ivoire in 2014 to that in 2015?
Keep it short and to the point. 1. What is the difference between the highest and the second highest Number of days of European Union?
Offer a terse response. 6.25. What is the difference between the highest and the second highest Number of days of Azerbaijan?
Keep it short and to the point. 0. What is the difference between the highest and the second highest Number of days of Cote d'Ivoire?
Your answer should be compact. 0. What is the difference between the highest and the second highest Number of days of Sao Tome and Principe?
Your answer should be very brief. 0. What is the difference between the highest and the lowest Number of days in European Union?
Make the answer very short. 46.67. What is the difference between the highest and the lowest Number of days of Cote d'Ivoire?
Your answer should be very brief. 245. What is the difference between the highest and the lowest Number of days in Sao Tome and Principe?
Keep it short and to the point. 120. 